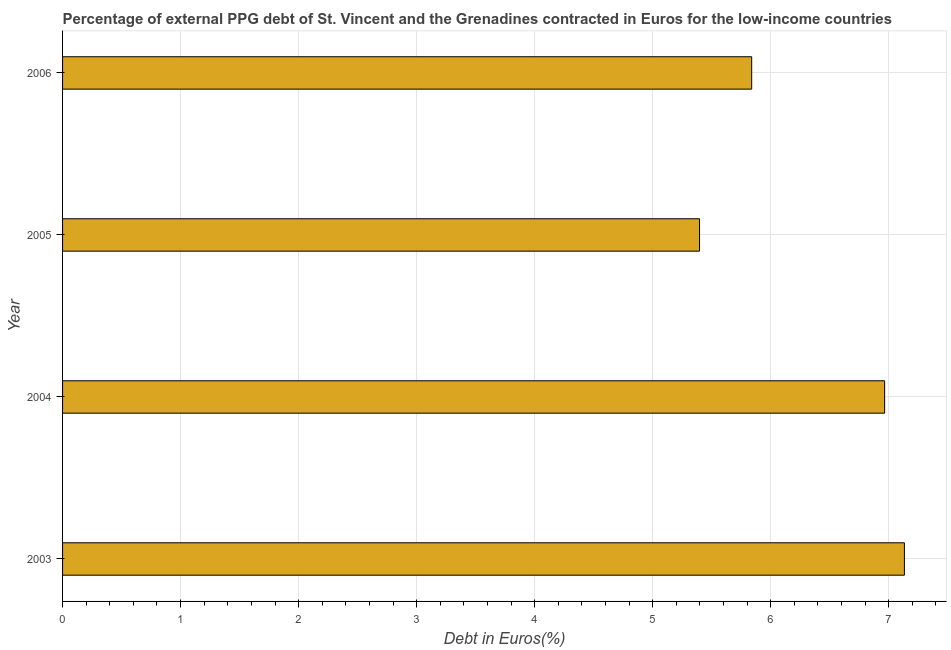Does the graph contain any zero values?
Give a very brief answer. No. Does the graph contain grids?
Offer a very short reply. Yes. What is the title of the graph?
Your answer should be very brief. Percentage of external PPG debt of St. Vincent and the Grenadines contracted in Euros for the low-income countries. What is the label or title of the X-axis?
Your answer should be very brief. Debt in Euros(%). What is the label or title of the Y-axis?
Provide a succinct answer. Year. What is the currency composition of ppg debt in 2003?
Offer a very short reply. 7.13. Across all years, what is the maximum currency composition of ppg debt?
Offer a terse response. 7.13. Across all years, what is the minimum currency composition of ppg debt?
Provide a short and direct response. 5.4. What is the sum of the currency composition of ppg debt?
Ensure brevity in your answer.  25.33. What is the difference between the currency composition of ppg debt in 2005 and 2006?
Offer a terse response. -0.44. What is the average currency composition of ppg debt per year?
Your response must be concise. 6.33. What is the median currency composition of ppg debt?
Make the answer very short. 6.4. In how many years, is the currency composition of ppg debt greater than 4 %?
Your answer should be compact. 4. Do a majority of the years between 2003 and 2004 (inclusive) have currency composition of ppg debt greater than 6.8 %?
Make the answer very short. Yes. What is the ratio of the currency composition of ppg debt in 2004 to that in 2005?
Your answer should be very brief. 1.29. Is the difference between the currency composition of ppg debt in 2004 and 2006 greater than the difference between any two years?
Make the answer very short. No. What is the difference between the highest and the second highest currency composition of ppg debt?
Give a very brief answer. 0.17. Is the sum of the currency composition of ppg debt in 2003 and 2005 greater than the maximum currency composition of ppg debt across all years?
Provide a short and direct response. Yes. What is the difference between the highest and the lowest currency composition of ppg debt?
Your response must be concise. 1.74. In how many years, is the currency composition of ppg debt greater than the average currency composition of ppg debt taken over all years?
Your answer should be compact. 2. How many years are there in the graph?
Your response must be concise. 4. What is the difference between two consecutive major ticks on the X-axis?
Your answer should be very brief. 1. Are the values on the major ticks of X-axis written in scientific E-notation?
Your answer should be very brief. No. What is the Debt in Euros(%) in 2003?
Keep it short and to the point. 7.13. What is the Debt in Euros(%) in 2004?
Your answer should be very brief. 6.96. What is the Debt in Euros(%) of 2005?
Make the answer very short. 5.4. What is the Debt in Euros(%) in 2006?
Make the answer very short. 5.84. What is the difference between the Debt in Euros(%) in 2003 and 2004?
Provide a short and direct response. 0.17. What is the difference between the Debt in Euros(%) in 2003 and 2005?
Keep it short and to the point. 1.74. What is the difference between the Debt in Euros(%) in 2003 and 2006?
Your response must be concise. 1.29. What is the difference between the Debt in Euros(%) in 2004 and 2005?
Offer a terse response. 1.57. What is the difference between the Debt in Euros(%) in 2004 and 2006?
Make the answer very short. 1.13. What is the difference between the Debt in Euros(%) in 2005 and 2006?
Your answer should be very brief. -0.44. What is the ratio of the Debt in Euros(%) in 2003 to that in 2005?
Ensure brevity in your answer.  1.32. What is the ratio of the Debt in Euros(%) in 2003 to that in 2006?
Offer a very short reply. 1.22. What is the ratio of the Debt in Euros(%) in 2004 to that in 2005?
Offer a terse response. 1.29. What is the ratio of the Debt in Euros(%) in 2004 to that in 2006?
Give a very brief answer. 1.19. What is the ratio of the Debt in Euros(%) in 2005 to that in 2006?
Give a very brief answer. 0.92. 